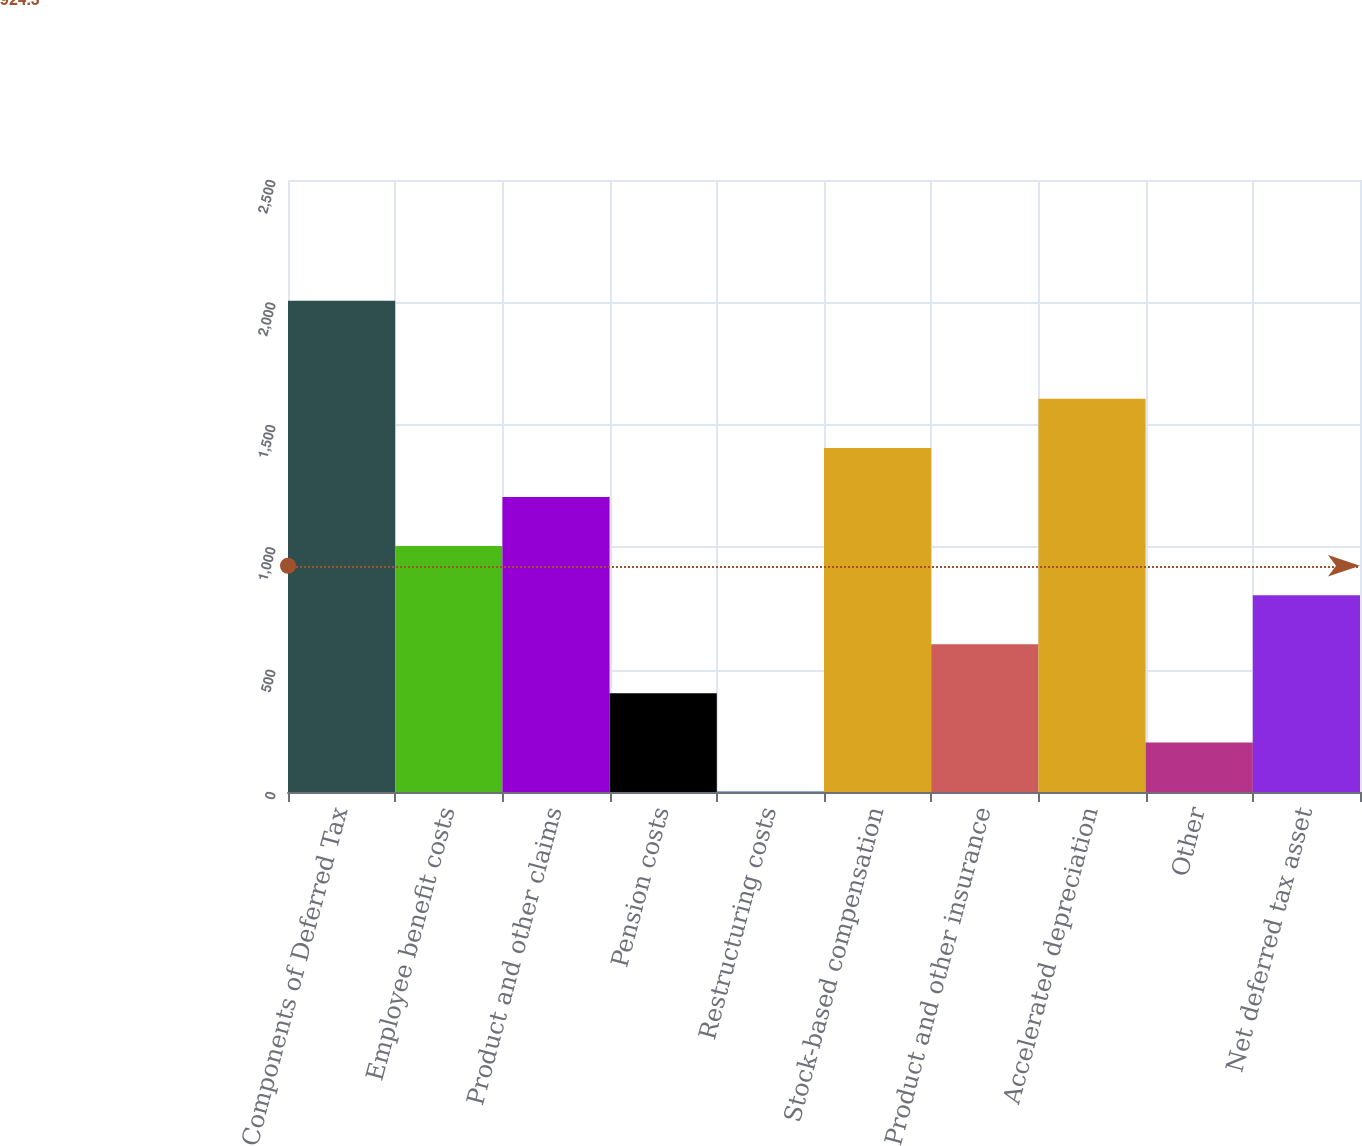<chart> <loc_0><loc_0><loc_500><loc_500><bar_chart><fcel>Components of Deferred Tax<fcel>Employee benefit costs<fcel>Product and other claims<fcel>Pension costs<fcel>Restructuring costs<fcel>Stock-based compensation<fcel>Product and other insurance<fcel>Accelerated depreciation<fcel>Other<fcel>Net deferred tax asset<nl><fcel>2007<fcel>1004.5<fcel>1205<fcel>403<fcel>2<fcel>1405.5<fcel>603.5<fcel>1606<fcel>202.5<fcel>804<nl></chart> 